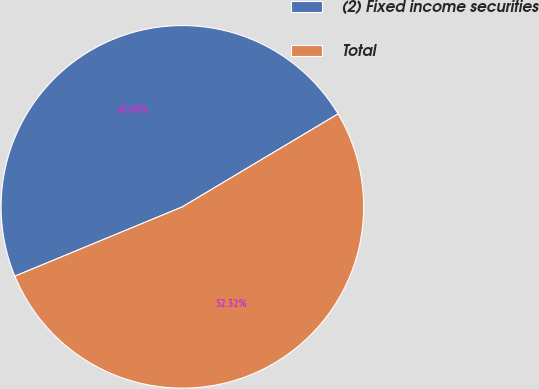<chart> <loc_0><loc_0><loc_500><loc_500><pie_chart><fcel>(2) Fixed income securities<fcel>Total<nl><fcel>47.68%<fcel>52.32%<nl></chart> 